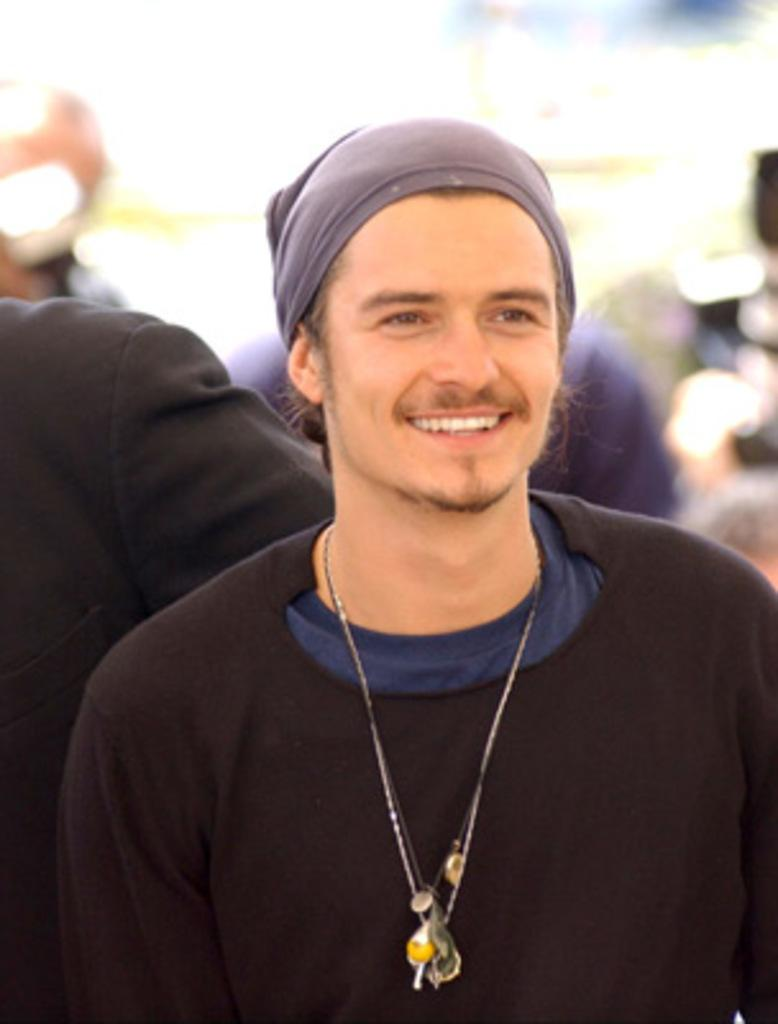What is the main subject of the image? There is a man in the image. What is the man wearing? The man is wearing a black T-shirt. What is the man's facial expression? The man is smiling. Can you describe the person behind the man? The person behind the man is wearing a black blazer. How would you describe the background of the image? The background of the image is blurred. What type of impulse can be seen affecting the man's behavior in the image? There is no indication of any impulse affecting the man's behavior in the image. Can you read the note that the man is holding in the image? There is no note present in the image. 